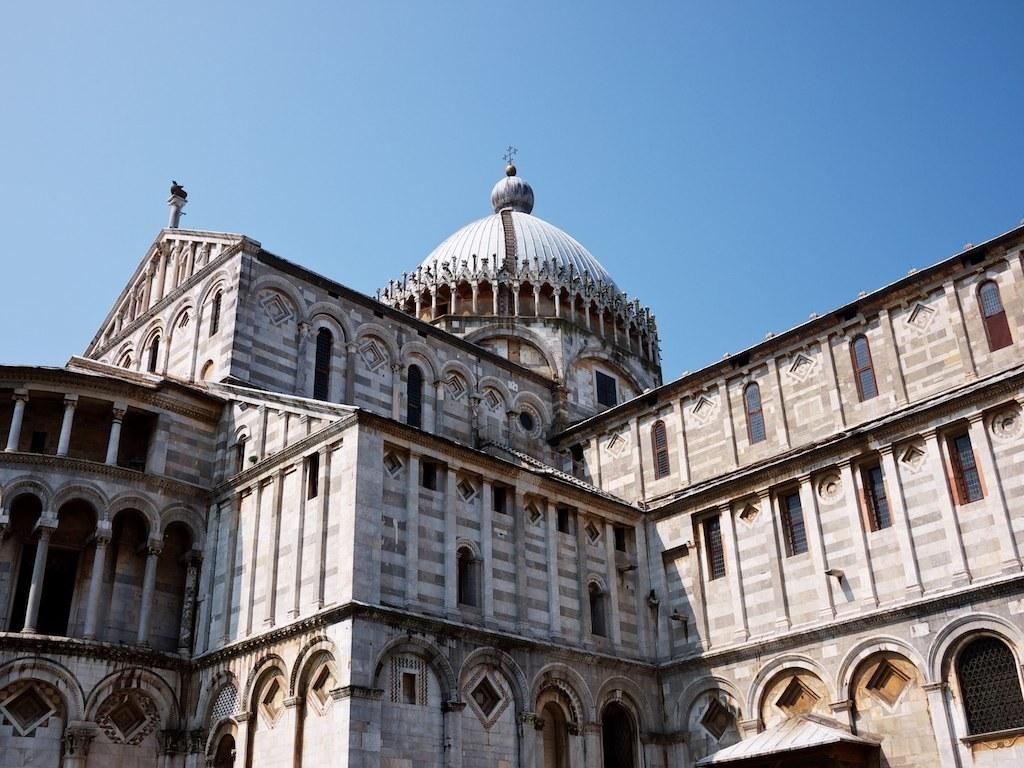What type of structure is present in the image? There is a building in the image. What architectural features can be seen on the building? The building has pillars and windows. What is visible at the top of the image? The sky is visible at the top of the image. What is the taste of the building in the image? Buildings do not have a taste, as they are inanimate objects made of materials like concrete, steel, or wood. 